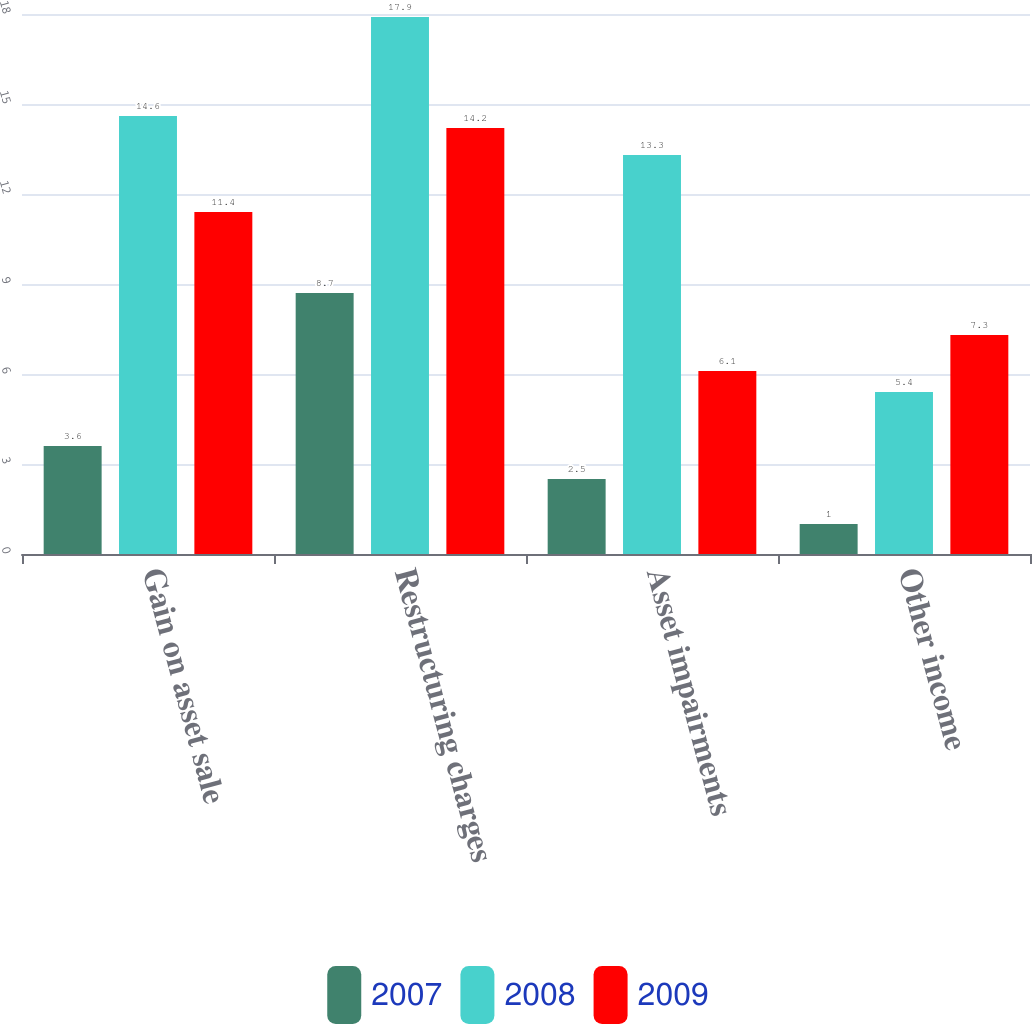<chart> <loc_0><loc_0><loc_500><loc_500><stacked_bar_chart><ecel><fcel>Gain on asset sale<fcel>Restructuring charges<fcel>Asset impairments<fcel>Other income<nl><fcel>2007<fcel>3.6<fcel>8.7<fcel>2.5<fcel>1<nl><fcel>2008<fcel>14.6<fcel>17.9<fcel>13.3<fcel>5.4<nl><fcel>2009<fcel>11.4<fcel>14.2<fcel>6.1<fcel>7.3<nl></chart> 